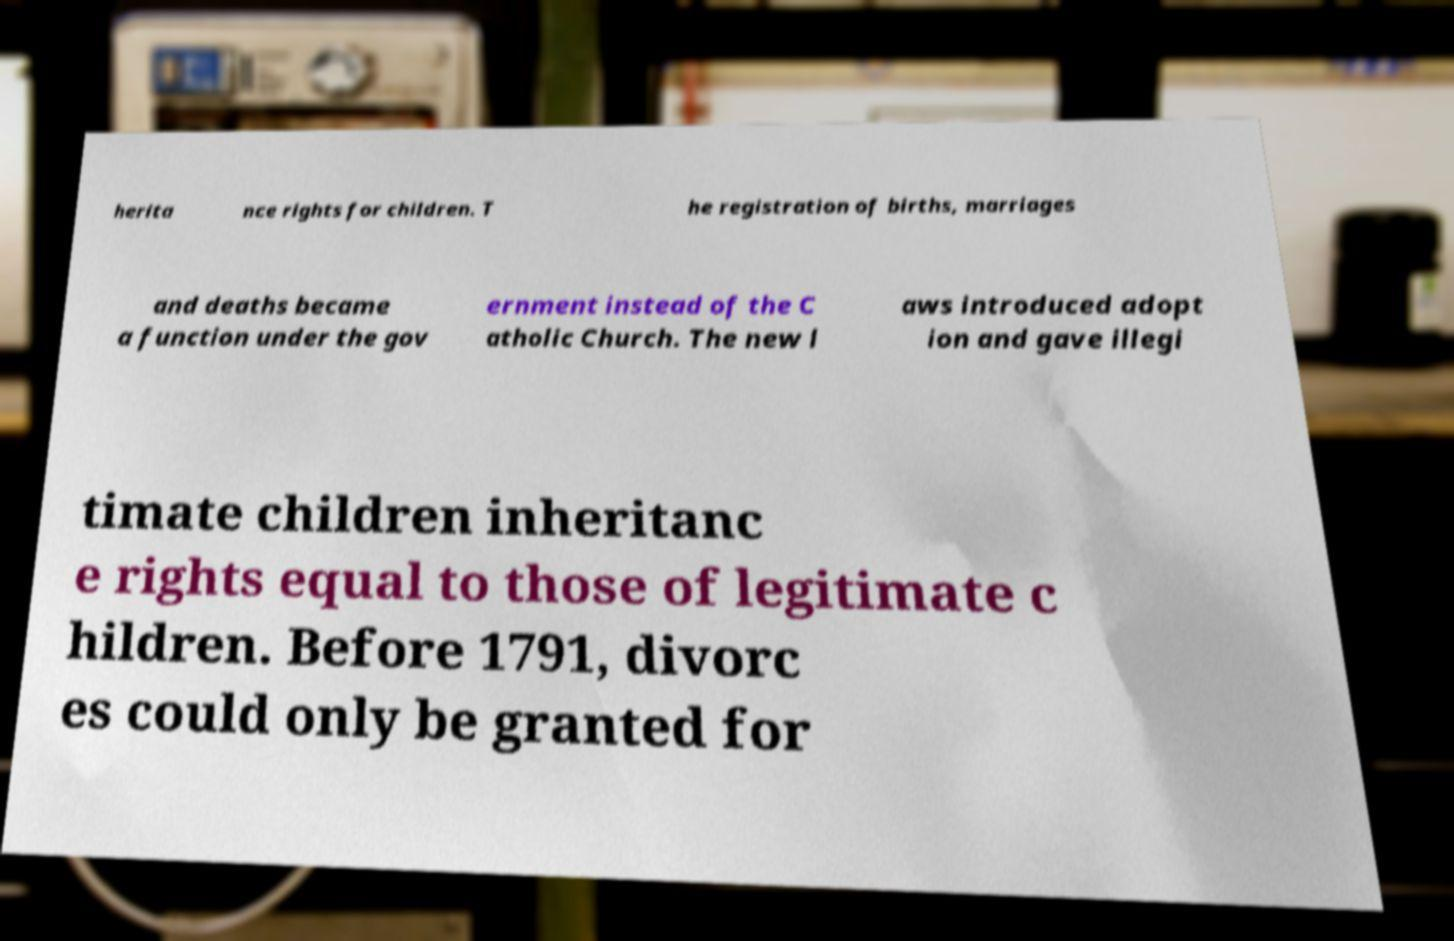Could you extract and type out the text from this image? herita nce rights for children. T he registration of births, marriages and deaths became a function under the gov ernment instead of the C atholic Church. The new l aws introduced adopt ion and gave illegi timate children inheritanc e rights equal to those of legitimate c hildren. Before 1791, divorc es could only be granted for 